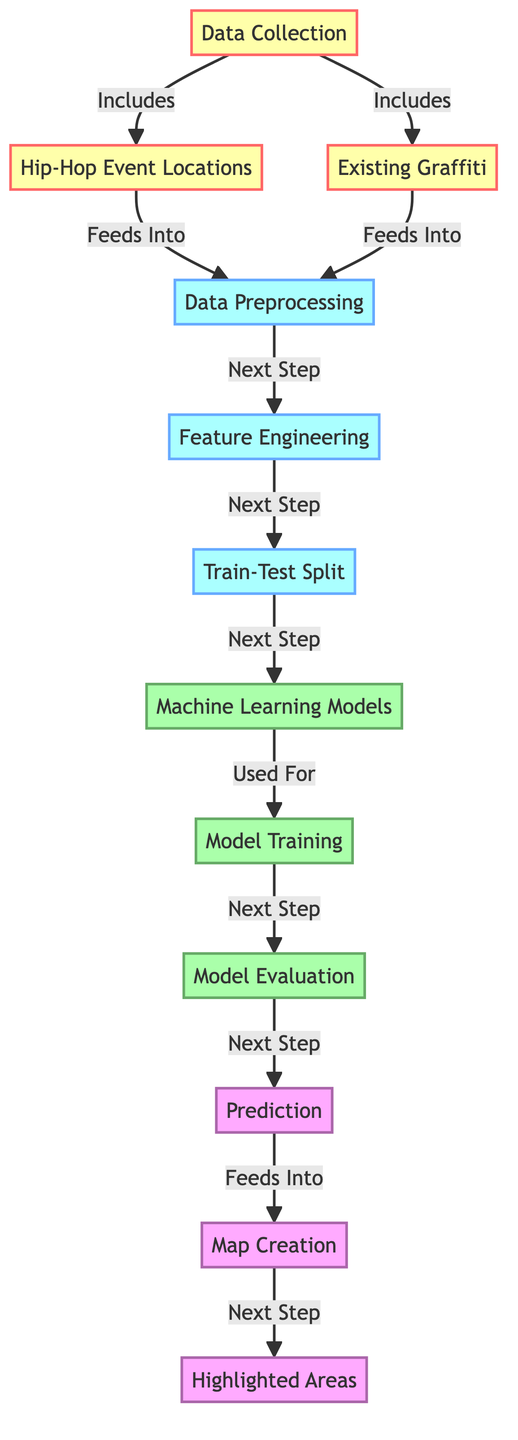What are the two main data sources for this diagram? The diagram indicates that the two main data sources are "Hip-Hop Event Locations" and "Existing Graffiti", both of which flow from "Data Collection".
Answer: Hip-Hop Event Locations, Existing Graffiti Which step comes after "Data Preprocessing"? In the flow of the diagram, after "Data Preprocessing", the next step is "Feature Engineering".
Answer: Feature Engineering How many model-related nodes are there in the diagram? The diagram contains four nodes related to models: "Machine Learning Models", "Model Training", "Model Evaluation", and "Prediction".
Answer: Four What is the output from the "Prediction" node? The diagram shows that the output from the "Prediction" node feeds into "Map Creation".
Answer: Map Creation If "Existing Graffiti" is absent, what would be the immediate downstream effect on "Data Preprocessing"? Without "Existing Graffiti", the "Data Preprocessing" node would not have complete data and would still proceed to process but have limited context for analysis, primarily relying on "Hip-Hop Event Locations".
Answer: Limited context for analysis Which node is responsible for creating the final visual output? The final visual output is created in the node labeled "Map Creation", which is the last processing step before highlighting areas.
Answer: Map Creation How does "Model Evaluation" relate to "Model Training"? The diagram indicates a direct progression where "Model Training" is evaluated in the next step by "Model Evaluation", suggesting that evaluation occurs after the training process.
Answer: Evaluation occurs after training What follows "Train-Test Split" in the sequence? After "Train-Test Split", the subsequent step is "Machine Learning Models", indicating a transition to model selection and application.
Answer: Machine Learning Models 